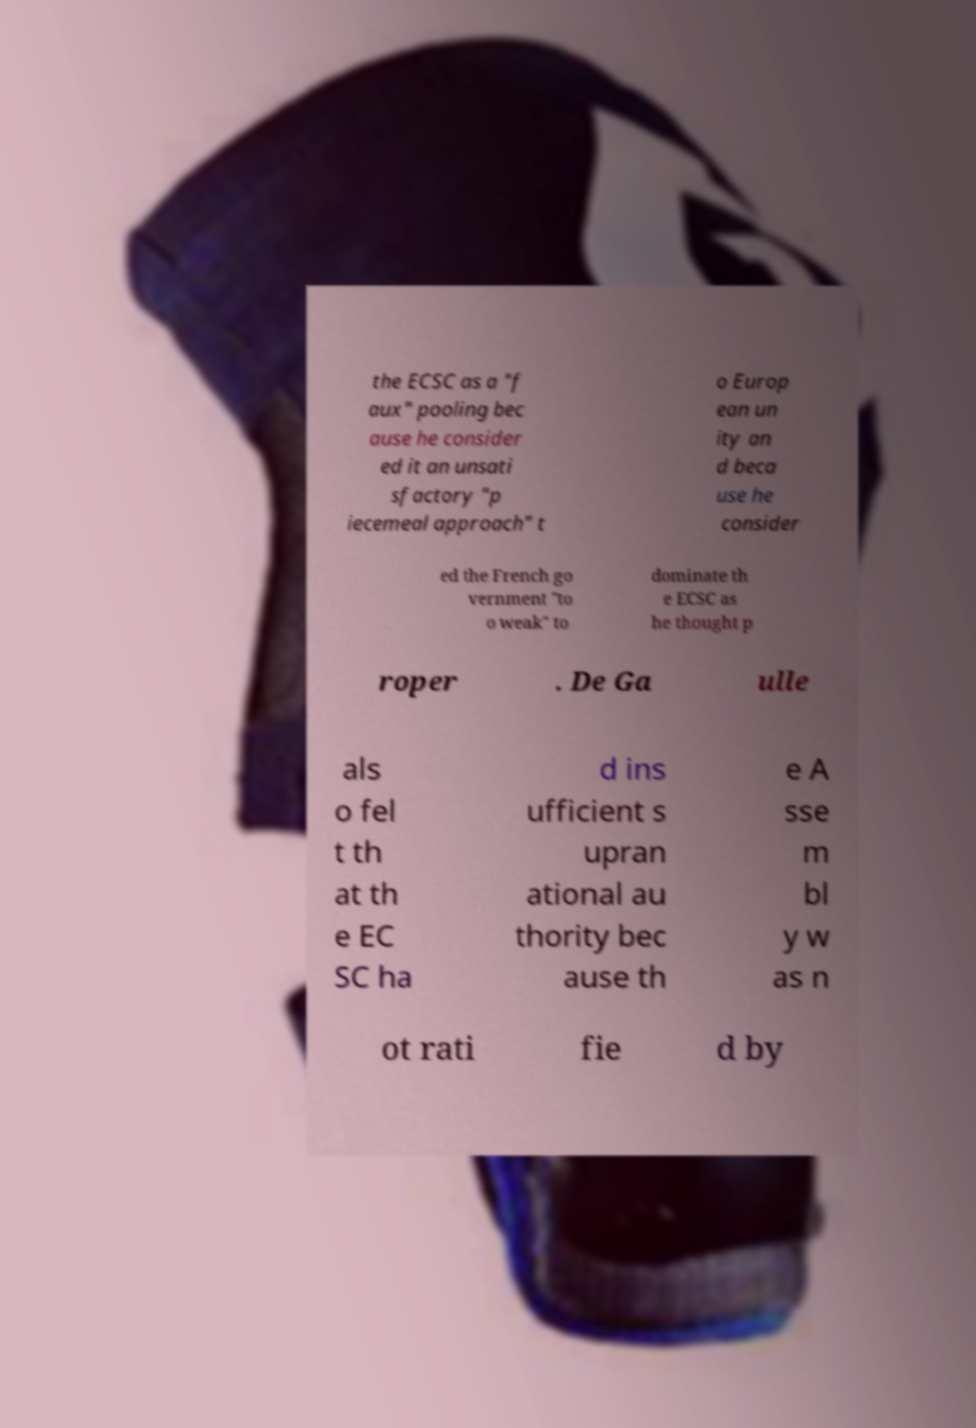There's text embedded in this image that I need extracted. Can you transcribe it verbatim? the ECSC as a "f aux" pooling bec ause he consider ed it an unsati sfactory "p iecemeal approach" t o Europ ean un ity an d beca use he consider ed the French go vernment "to o weak" to dominate th e ECSC as he thought p roper . De Ga ulle als o fel t th at th e EC SC ha d ins ufficient s upran ational au thority bec ause th e A sse m bl y w as n ot rati fie d by 